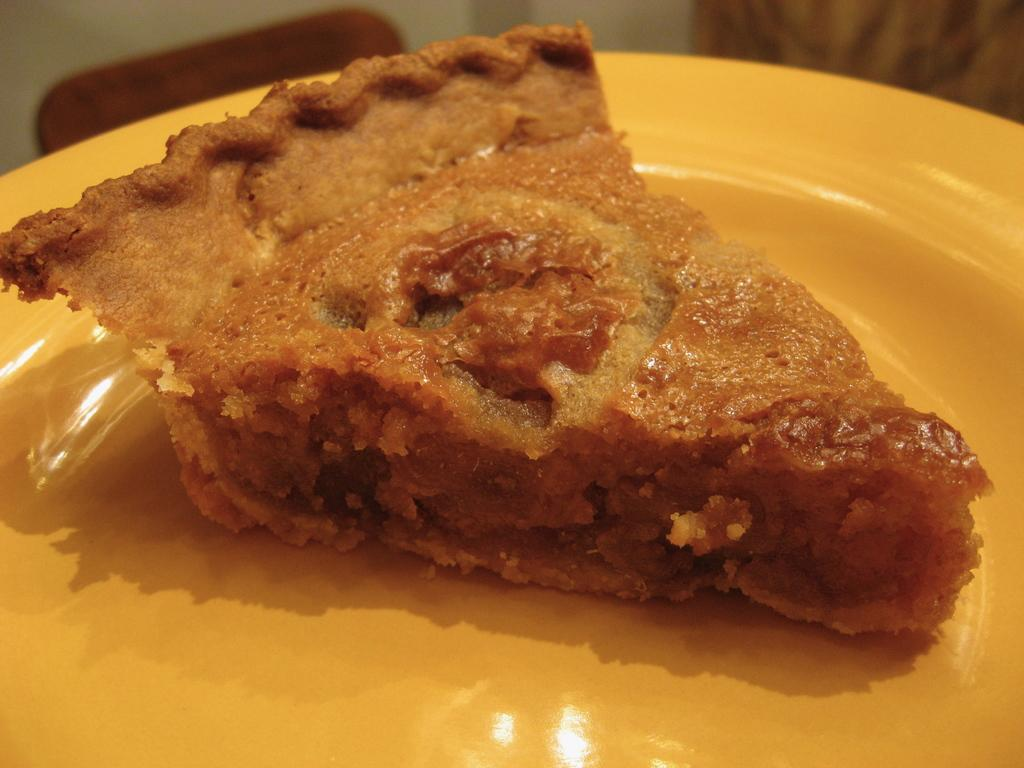What is on the plate in the image? There is a food item on a plate in the image. How many goats are visible in the image? There are no goats present in the image. What is the position of the cattle in the image? There is no cattle present in the image. 